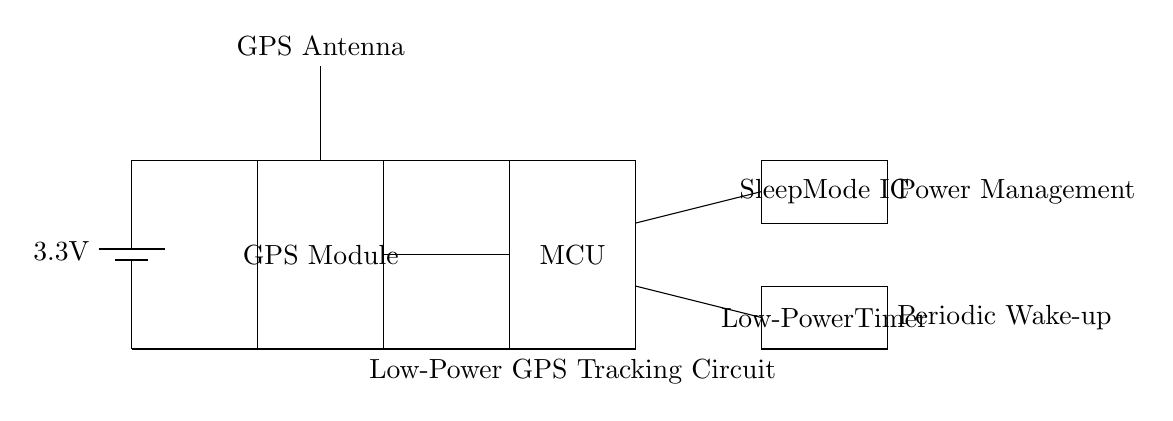What is the voltage supply for this circuit? The circuit uses a battery marked as a 3.3V power supply, which is indicated at the top left of the diagram. This is the voltage that powers the entire circuit.
Answer: 3.3V What component is used for GPS tracking? The component labeled as "GPS Module" is specifically designed for receiving GPS signals, allowing for location tracking during trail rides.
Answer: GPS Module How does the circuit manage low power consumption? The circuit includes components like the "Low-Power Timer" and "Sleep Mode IC," which are essential for managing power consumption effectively, ensuring minimal battery usage when not active.
Answer: Low-Power Timer, Sleep Mode IC What is the purpose of the antenna in the circuit? The antenna, indicated at the top of the diagram, is used to receive GPS signals. It is crucial for the GPS module to function correctly and communicate with satellites.
Answer: Receive GPS signals How many main components are shown in the diagram? The diagram presents five main components: a battery, a GPS module, a microcontroller, a low-power timer, and a sleep mode IC. Counting these gives a total of five.
Answer: Five What type of circuit is depicted in the diagram? The circuit is a low-power GPS tracking circuit, designed for efficient operation with minimal energy usage, particularly important for off-road vehicles like the Jeep Wrangler.
Answer: Low-power GPS tracking circuit 